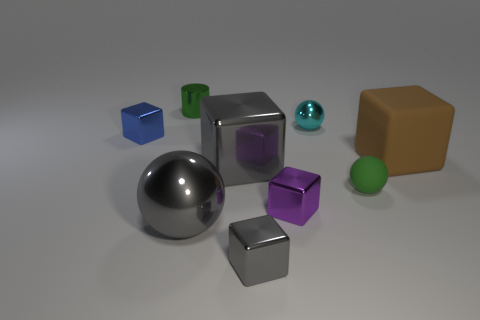Subtract all shiny cubes. How many cubes are left? 1 Subtract all brown cubes. How many cubes are left? 4 Subtract 0 red blocks. How many objects are left? 9 Subtract all cubes. How many objects are left? 4 Subtract 4 cubes. How many cubes are left? 1 Subtract all yellow blocks. Subtract all cyan spheres. How many blocks are left? 5 Subtract all gray blocks. How many brown cylinders are left? 0 Subtract all cyan metallic blocks. Subtract all large gray metal spheres. How many objects are left? 8 Add 8 tiny blue objects. How many tiny blue objects are left? 9 Add 1 large blocks. How many large blocks exist? 3 